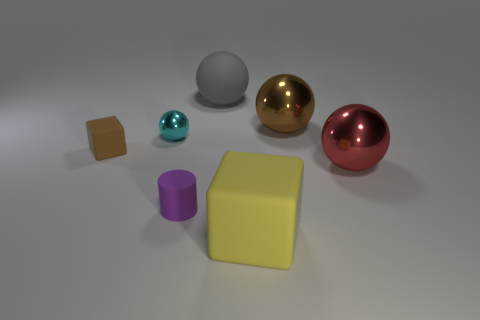Add 3 purple matte cubes. How many objects exist? 10 Subtract all balls. How many objects are left? 3 Add 5 big yellow spheres. How many big yellow spheres exist? 5 Subtract 0 blue cylinders. How many objects are left? 7 Subtract all large red shiny balls. Subtract all purple cylinders. How many objects are left? 5 Add 1 yellow rubber blocks. How many yellow rubber blocks are left? 2 